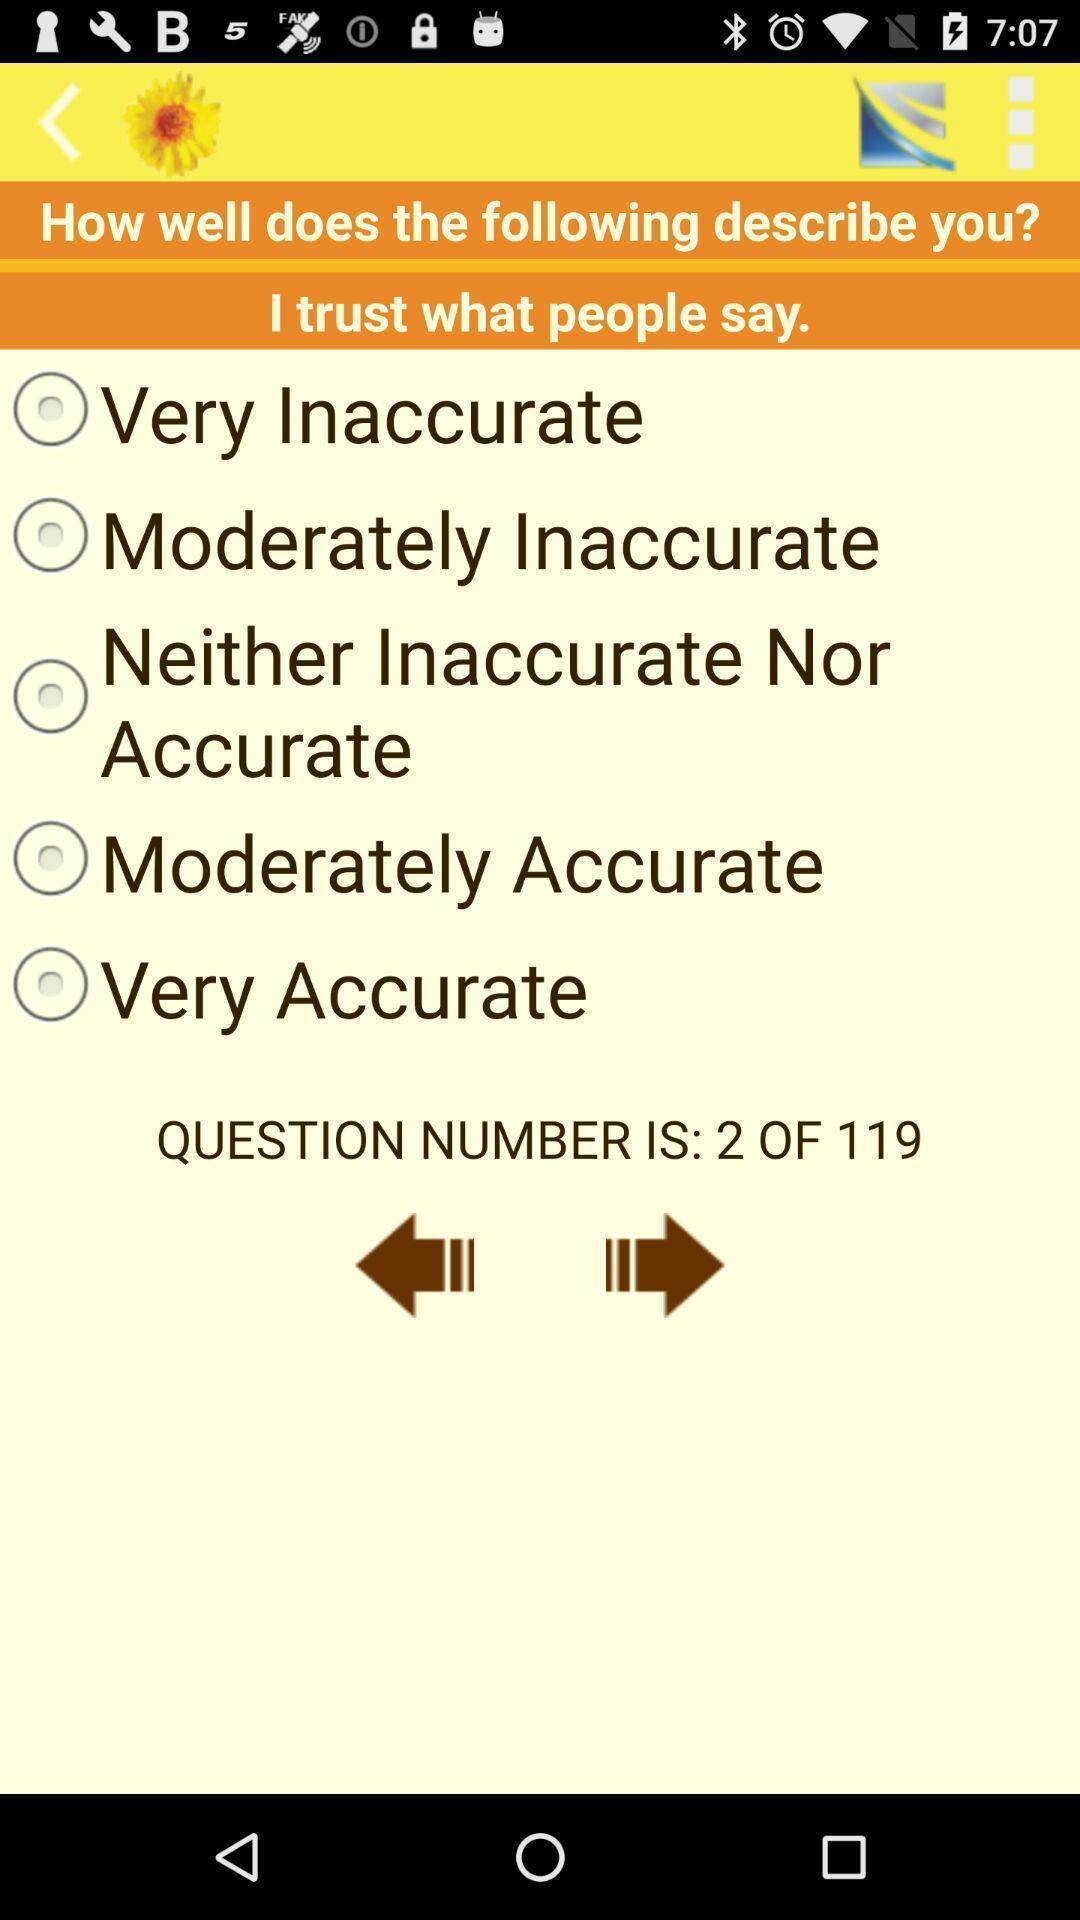Describe the key features of this screenshot. Screen displaying the options for rating. 